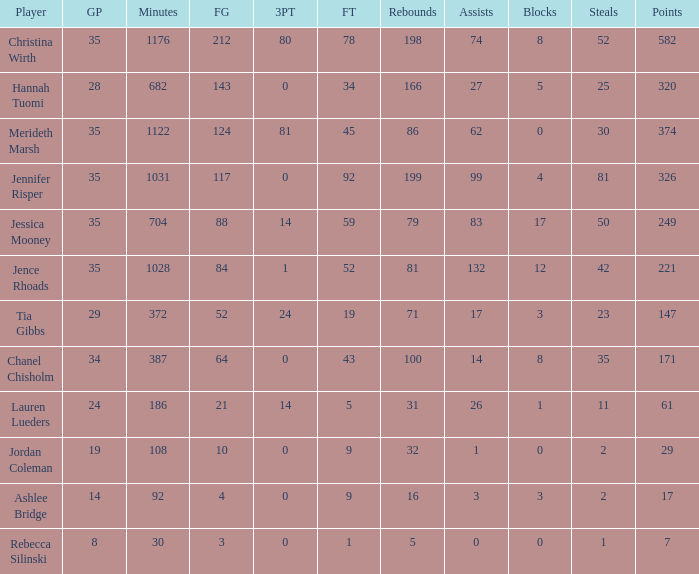How many years did jordan coleman actively play? 108.0. 